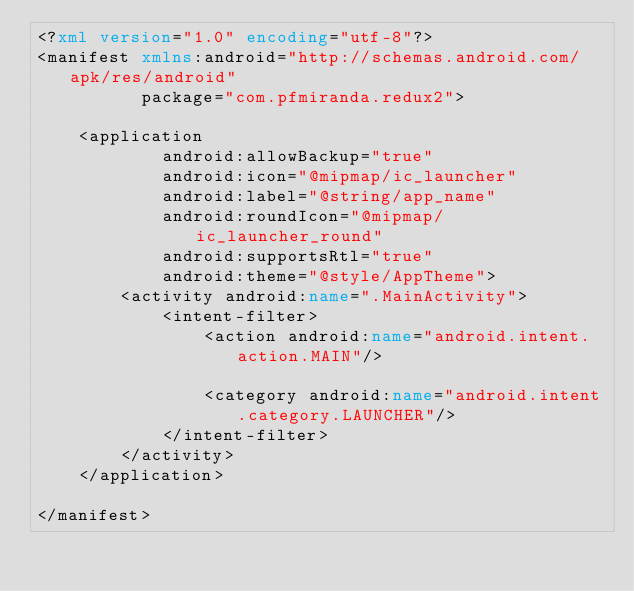<code> <loc_0><loc_0><loc_500><loc_500><_XML_><?xml version="1.0" encoding="utf-8"?>
<manifest xmlns:android="http://schemas.android.com/apk/res/android"
          package="com.pfmiranda.redux2">

    <application
            android:allowBackup="true"
            android:icon="@mipmap/ic_launcher"
            android:label="@string/app_name"
            android:roundIcon="@mipmap/ic_launcher_round"
            android:supportsRtl="true"
            android:theme="@style/AppTheme">
        <activity android:name=".MainActivity">
            <intent-filter>
                <action android:name="android.intent.action.MAIN"/>

                <category android:name="android.intent.category.LAUNCHER"/>
            </intent-filter>
        </activity>
    </application>

</manifest></code> 